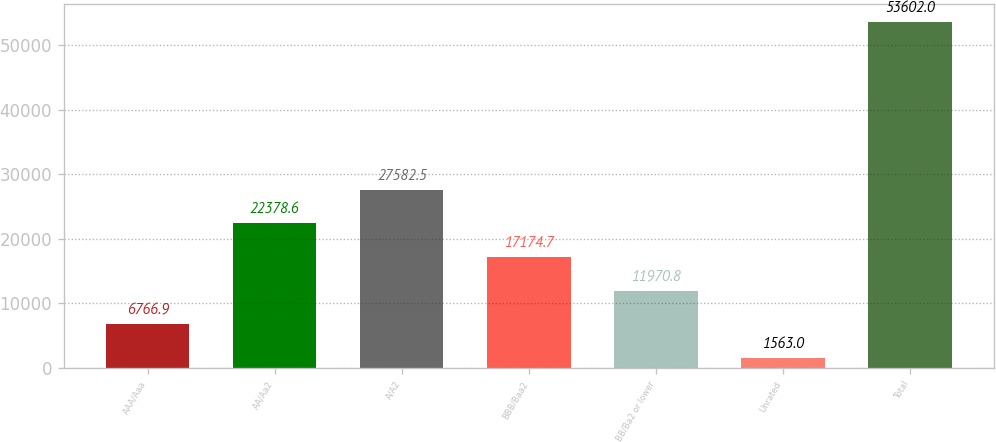Convert chart. <chart><loc_0><loc_0><loc_500><loc_500><bar_chart><fcel>AAA/Aaa<fcel>AA/Aa2<fcel>A/A2<fcel>BBB/Baa2<fcel>BB/Ba2 or lower<fcel>Unrated<fcel>Total<nl><fcel>6766.9<fcel>22378.6<fcel>27582.5<fcel>17174.7<fcel>11970.8<fcel>1563<fcel>53602<nl></chart> 